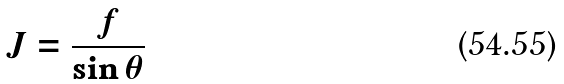<formula> <loc_0><loc_0><loc_500><loc_500>J = \frac { f } { \sin \theta }</formula> 